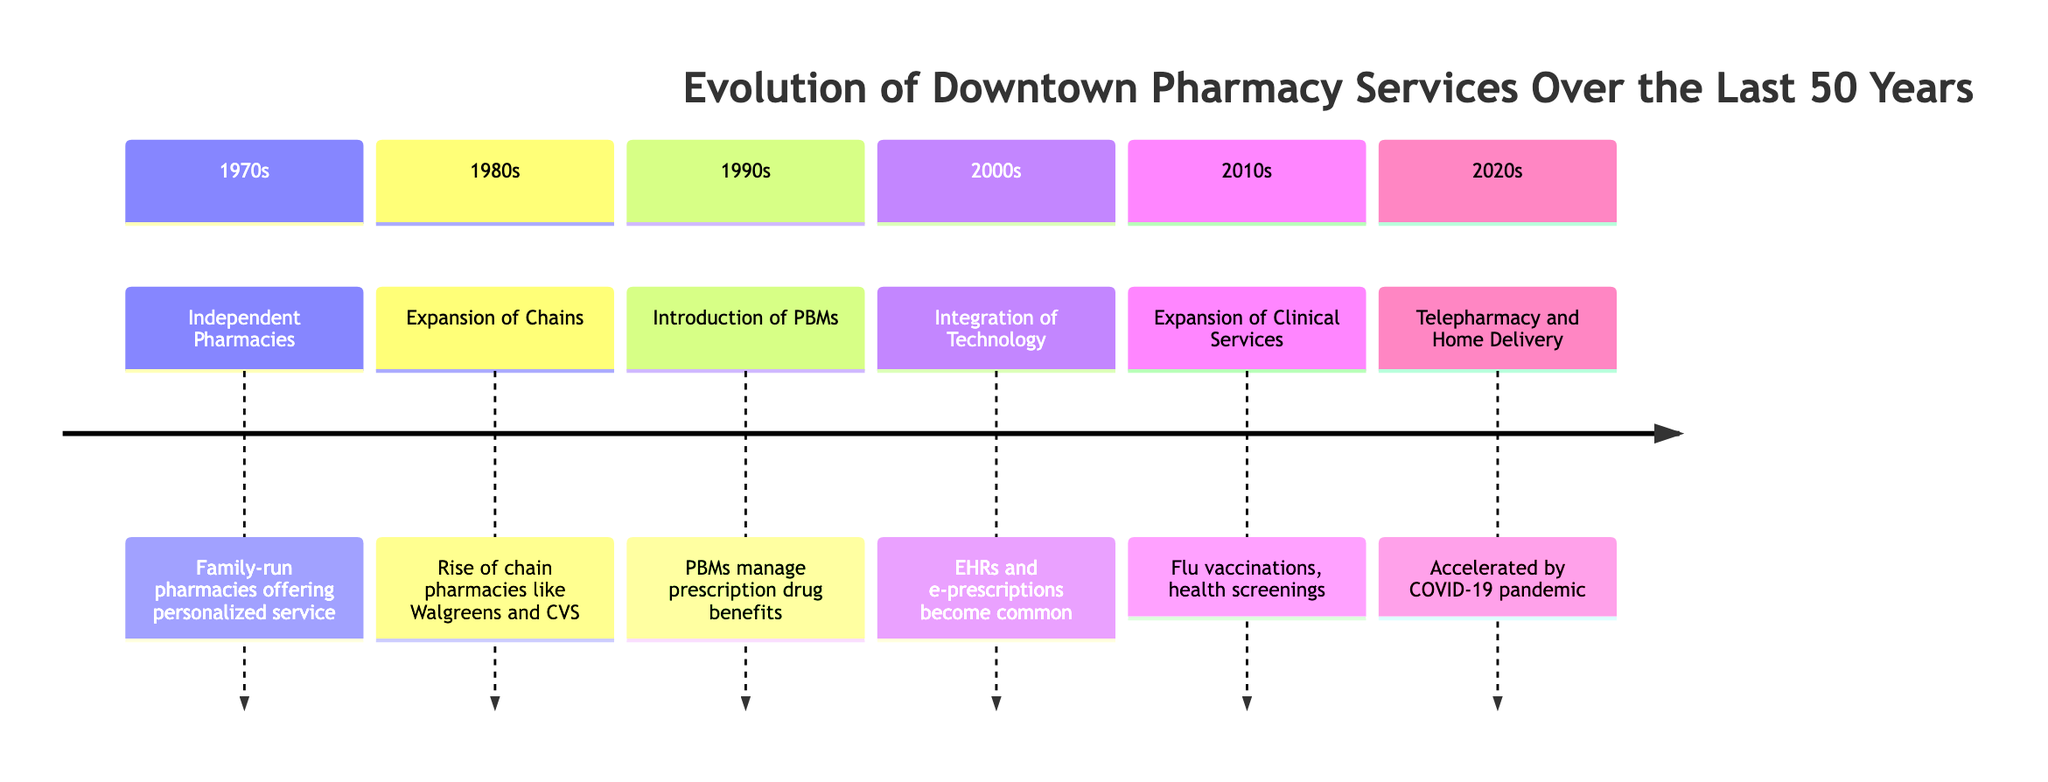What was the primary service type in the 1970s? The diagram indicates that the primary service type in the 1970s was "Independent Pharmacies," which are family-run and focus on personalized service. This can be found in the timeline section for the 1970s.
Answer: Independent Pharmacies Which decade saw the introduction of Pharmacy Benefits Managers? According to the timeline, the decade in which Pharmacy Benefits Managers were introduced is the 1990s. The relevant section clearly states this service type.
Answer: 1990s What type of service increased during the 2010s? The diagram specifies that during the 2010s, there was an "Expansion of Clinical Services," indicating a focus on more health-related services provided by pharmacies. This information can be directly found in the section for the 2010s.
Answer: Expansion of Clinical Services In which decade did technology integration significantly change pharmacy services? The diagram shows that the integration of technology occurred in the 2000s, where electronic health records and e-prescriptions became common. This is referenced in the corresponding timeline section for the 2000s.
Answer: 2000s How did the role of pharmacies change in the 2020s? The timeline indicates that in the 2020s, there was a significant shift towards "Telepharmacy and Home Delivery," primarily accelerated by the COVID-19 pandemic. This transition is detailed in the section for the 2020s.
Answer: Telepharmacy and Home Delivery What impact did the expansion of chains have on community engagement? The diagram's sentiment notes point out that the rise of large chain pharmacies led to a "Diminished sense of community," illustrating the emotional impact this change had on personal connections within the community.
Answer: Diminished sense of community Which services are associated with the 2010s, according to the diagram? The diagram clearly states that the 2010s are associated with the "Expansion of Clinical Services," which includes health screenings and flu vaccinations, thus detailing the services offered in that decade.
Answer: Health screenings, flu vaccinations What sentiment reflects the decline of independent pharmacies? The sentiment notes in the diagram express "Loss of personalized service as independent pharmacies declined," highlighting the emotional response to this change in the pharmacy landscape.
Answer: Loss of personalized service How did the use of technology in pharmacies affect face-to-face interactions? The sentiment notes indicate that the integration of technology has led to "Mixed feelings about technology reducing face-to-face interactions," illustrating the emotional conflict regarding technological advancements.
Answer: Mixed feelings about technology reducing face-to-face interactions 